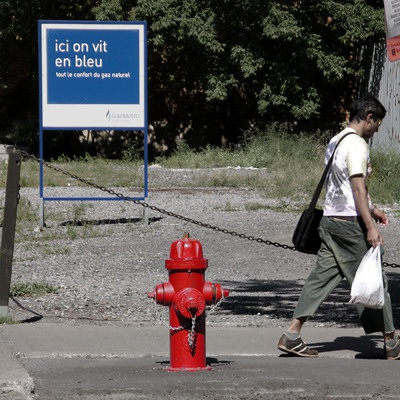Describe the objects in this image and their specific colors. I can see people in black, gray, white, and darkgray tones, fire hydrant in black, brown, and maroon tones, handbag in black, gray, lightgray, and darkgray tones, and backpack in black and gray tones in this image. 